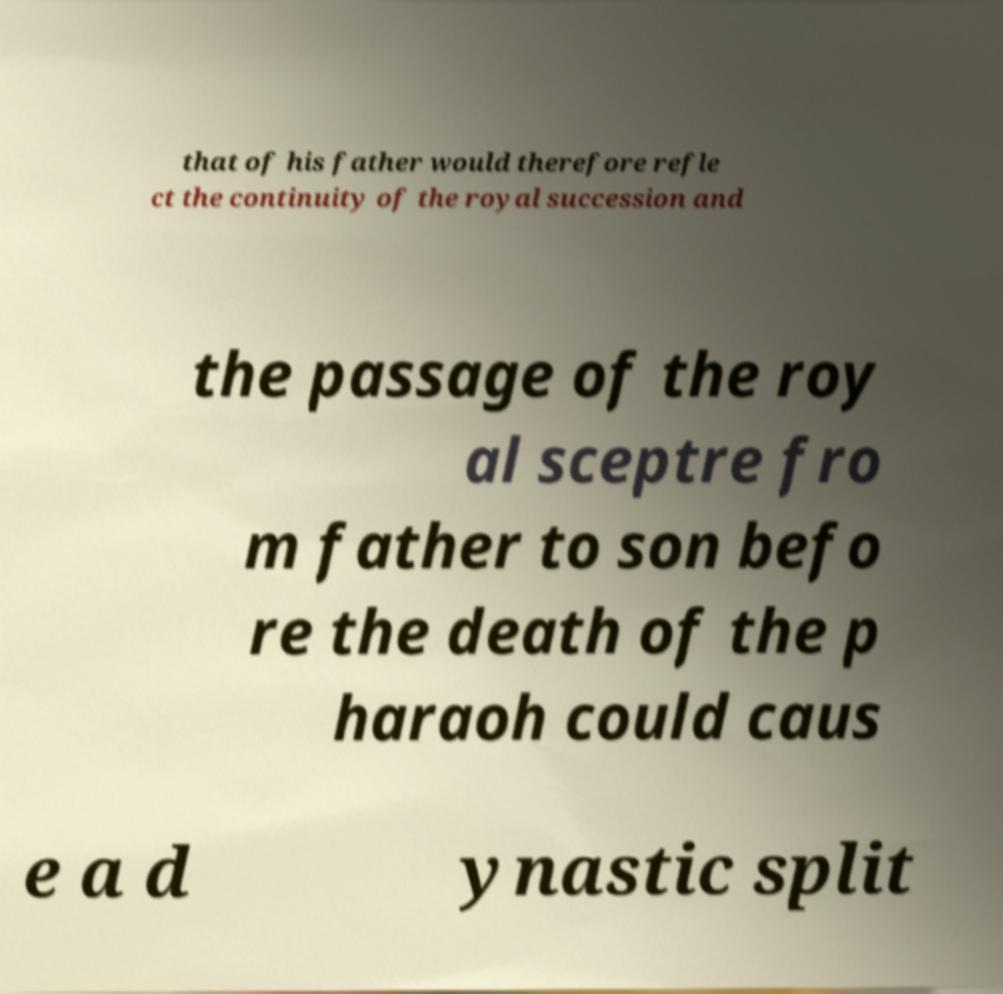There's text embedded in this image that I need extracted. Can you transcribe it verbatim? that of his father would therefore refle ct the continuity of the royal succession and the passage of the roy al sceptre fro m father to son befo re the death of the p haraoh could caus e a d ynastic split 